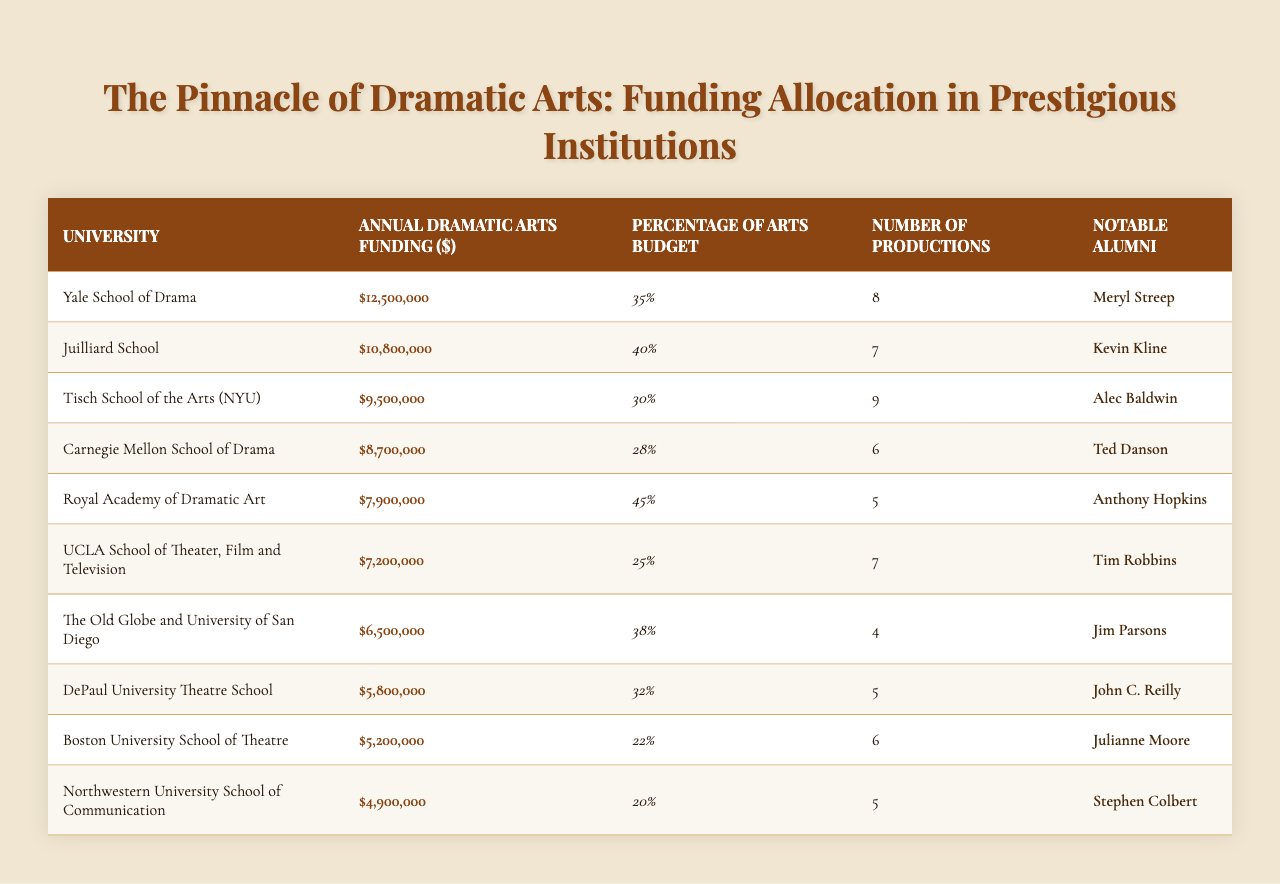What university has the highest annual funding for dramatic arts? Looking at the table, Yale School of Drama has the highest funding, which is $12,500,000.
Answer: Yale School of Drama What percentage of the arts budget does Juilliard School allocate to dramatic arts? The table shows that Juilliard School allocates 40% of its arts budget to dramatic arts.
Answer: 40% How many productions does the Royal Academy of Dramatic Art have per year? According to the table, the Royal Academy of Dramatic Art has 5 productions each year.
Answer: 5 Which university has the lowest funding for dramatic arts? The table indicates that Northwestern University School of Communication has the lowest funding at $4,900,000.
Answer: Northwestern University School of Communication What is the total funding allocated to dramatic arts across all listed universities? By adding the annual funding amounts ($12,500,000 + $10,800,000 + $9,500,000 + $8,700,000 + $7,900,000 + $7,200,000 + $6,500,000 + $5,800,000 + $5,200,000 + $4,900,000), we find the total to be $79,000,000.
Answer: $79,000,000 Is there a university that allocates exactly 30% of its budget to dramatic arts? The table shows that Tisch School of the Arts (NYU) allocates exactly 30% of its budget to dramatic arts, hence the answer is yes.
Answer: Yes How does the number of productions correlate with the annual funding for dramatic arts? Analyzing the table, the university with the highest funding (Yale School of Drama) has 8 productions, while the one with the second lowest funding (Boston University) has 6 productions. This suggests no clear correlation.
Answer: No clear correlation Which notable alumni attended the schools with the three highest funding allocations? From the table, the notable alumni from the top three funded schools are: Meryl Streep from Yale, Kevin Kline from Juilliard, and Alec Baldwin from Tisch.
Answer: Meryl Streep, Kevin Kline, Alec Baldwin What is the average percentage of the arts budget allocated to dramatic arts among the schools? To find the average, add the percentages (35 + 40 + 30 + 28 + 45 + 25 + 38 + 32 + 22 + 20 =  365), then divide by the number of universities (10). Thus, the average percentage is 36.5%.
Answer: 36.5% Which university has a funding amount closest to $7,000,000? By checking the funding amounts, UCLA School of Theater, Film and Television has $7,200,000, which is the closest to $7,000,000.
Answer: UCLA School of Theater, Film and Television 